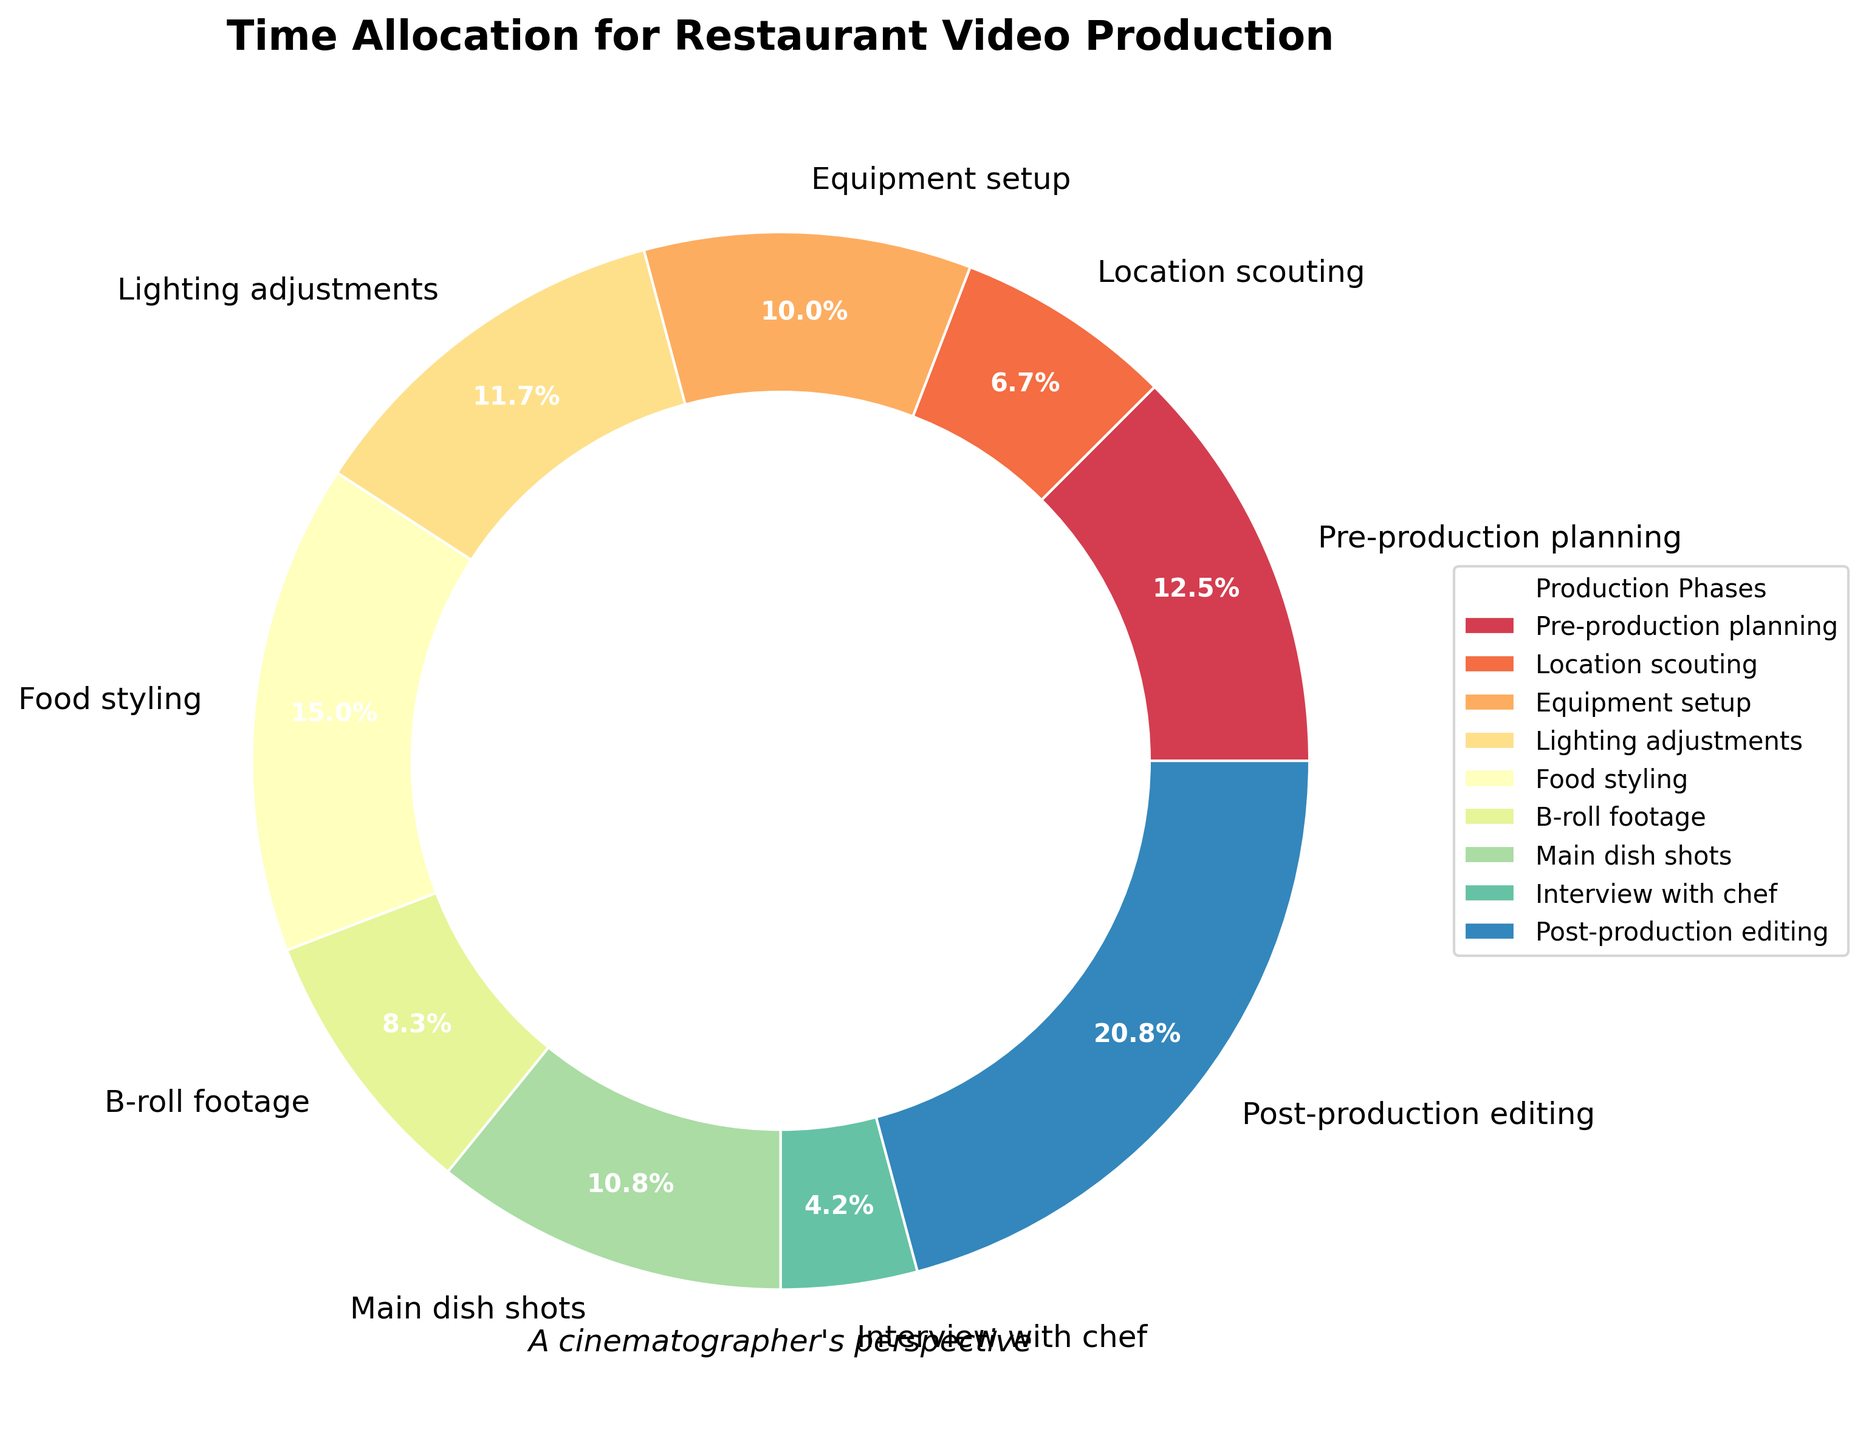What's the total time allocation for Equipment setup, Lighting adjustments, and Food styling? The time allocation for Equipment setup is 12%, for Lighting adjustments is 14%, and for Food styling is 18%. Adding these together: 12% + 14% + 18% = 44%.
Answer: 44% Which phase has the smallest time allocation? Looking at the pie chart, we see the smallest wedge represents the Interview with chef phase at 5%.
Answer: Interview with chef Which two phases together make up more than 30% of the total time? The phases with the highest percentages are Post-production editing (25%) and Food styling (18%). Since 18% + 25% > 30%, these two phases together make up more than 30%.
Answer: Post-production editing and Food styling Is the time allocated to B-roll footage greater than that to the Interview with chef? The time allocation for B-roll footage is 10%, and for the Interview with chef is 5%. Since 10% > 5%, B-roll footage has a greater percentage.
Answer: Yes What's the combined time allocation for Location scouting and Main dish shots? The time allocation for Location scouting is 8% and for Main dish shots is 13%. Adding these together: 8% + 13% = 21%.
Answer: 21% Which phase has a time allocation that's closest to but less than 15%? The time allocations closest to 15% but less are for Main dish shots (13%) and Equipment setup (12%). Main dish shots are the closest.
Answer: Main dish shots How much more time is allocated to Pre-production planning compared to Interview with chef? The time allocation for Pre-production planning is 15%, and for the Interview with chef is 5%. Subtracting these: 15% - 5% = 10%.
Answer: 10% What proportion of time is spent on shooting-related phases (B-roll footage and Main dish shots) combined? The time allocation for B-roll footage is 10%, and for Main dish shots is 13%. Adding these together: 10% + 13% = 23%.
Answer: 23% What's the approximate difference in time allocation between Post-production editing and the second highest time-allocated phase? Post-production editing has the highest time allocation (25%), and the second highest is Food styling (18%). The difference is 25% - 18% = 7%.
Answer: 7% Compare the combined time allocation for Pre-production planning and Lighting adjustments with the time allocated to Post-production editing. Which is higher? The combined time allocation for Pre-production planning (15%) and Lighting adjustments (14%) is 15% + 14% = 29%. Post-production editing is 25%. Since 29% > 25%, the combined allocation for the former two phases is higher.
Answer: Pre-production planning and Lighting adjustments 